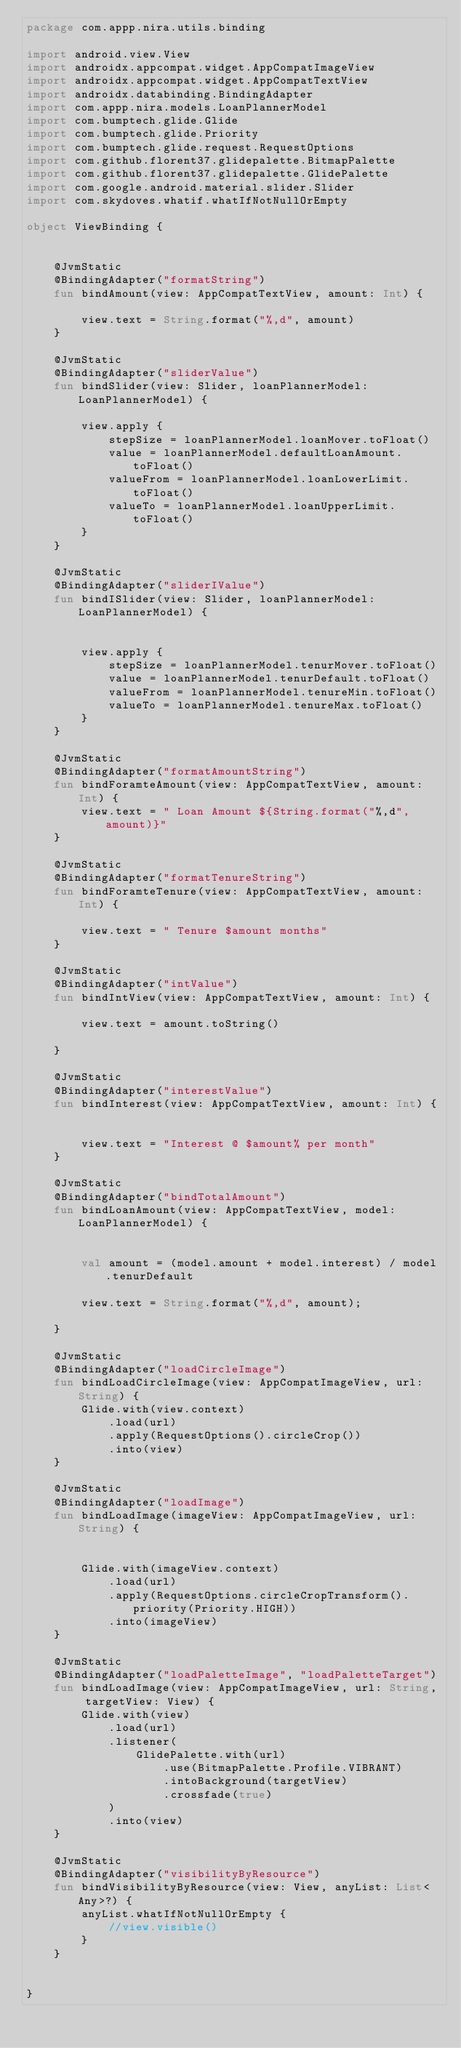Convert code to text. <code><loc_0><loc_0><loc_500><loc_500><_Kotlin_>package com.appp.nira.utils.binding

import android.view.View
import androidx.appcompat.widget.AppCompatImageView
import androidx.appcompat.widget.AppCompatTextView
import androidx.databinding.BindingAdapter
import com.appp.nira.models.LoanPlannerModel
import com.bumptech.glide.Glide
import com.bumptech.glide.Priority
import com.bumptech.glide.request.RequestOptions
import com.github.florent37.glidepalette.BitmapPalette
import com.github.florent37.glidepalette.GlidePalette
import com.google.android.material.slider.Slider
import com.skydoves.whatif.whatIfNotNullOrEmpty

object ViewBinding {


    @JvmStatic
    @BindingAdapter("formatString")
    fun bindAmount(view: AppCompatTextView, amount: Int) {

        view.text = String.format("%,d", amount)
    }

    @JvmStatic
    @BindingAdapter("sliderValue")
    fun bindSlider(view: Slider, loanPlannerModel: LoanPlannerModel) {

        view.apply {
            stepSize = loanPlannerModel.loanMover.toFloat()
            value = loanPlannerModel.defaultLoanAmount.toFloat()
            valueFrom = loanPlannerModel.loanLowerLimit.toFloat()
            valueTo = loanPlannerModel.loanUpperLimit.toFloat()
        }
    }

    @JvmStatic
    @BindingAdapter("sliderIValue")
    fun bindISlider(view: Slider, loanPlannerModel: LoanPlannerModel) {


        view.apply {
            stepSize = loanPlannerModel.tenurMover.toFloat()
            value = loanPlannerModel.tenurDefault.toFloat()
            valueFrom = loanPlannerModel.tenureMin.toFloat()
            valueTo = loanPlannerModel.tenureMax.toFloat()
        }
    }

    @JvmStatic
    @BindingAdapter("formatAmountString")
    fun bindForamteAmount(view: AppCompatTextView, amount: Int) {
        view.text = " Loan Amount ${String.format("%,d", amount)}"
    }

    @JvmStatic
    @BindingAdapter("formatTenureString")
    fun bindForamteTenure(view: AppCompatTextView, amount: Int) {

        view.text = " Tenure $amount months"
    }

    @JvmStatic
    @BindingAdapter("intValue")
    fun bindIntView(view: AppCompatTextView, amount: Int) {

        view.text = amount.toString()

    }

    @JvmStatic
    @BindingAdapter("interestValue")
    fun bindInterest(view: AppCompatTextView, amount: Int) {


        view.text = "Interest @ $amount% per month"
    }

    @JvmStatic
    @BindingAdapter("bindTotalAmount")
    fun bindLoanAmount(view: AppCompatTextView, model: LoanPlannerModel) {


        val amount = (model.amount + model.interest) / model.tenurDefault

        view.text = String.format("%,d", amount);

    }

    @JvmStatic
    @BindingAdapter("loadCircleImage")
    fun bindLoadCircleImage(view: AppCompatImageView, url: String) {
        Glide.with(view.context)
            .load(url)
            .apply(RequestOptions().circleCrop())
            .into(view)
    }

    @JvmStatic
    @BindingAdapter("loadImage")
    fun bindLoadImage(imageView: AppCompatImageView, url: String) {


        Glide.with(imageView.context)
            .load(url)
            .apply(RequestOptions.circleCropTransform().priority(Priority.HIGH))
            .into(imageView)
    }

    @JvmStatic
    @BindingAdapter("loadPaletteImage", "loadPaletteTarget")
    fun bindLoadImage(view: AppCompatImageView, url: String, targetView: View) {
        Glide.with(view)
            .load(url)
            .listener(
                GlidePalette.with(url)
                    .use(BitmapPalette.Profile.VIBRANT)
                    .intoBackground(targetView)
                    .crossfade(true)
            )
            .into(view)
    }

    @JvmStatic
    @BindingAdapter("visibilityByResource")
    fun bindVisibilityByResource(view: View, anyList: List<Any>?) {
        anyList.whatIfNotNullOrEmpty {
            //view.visible()
        }
    }


}
</code> 